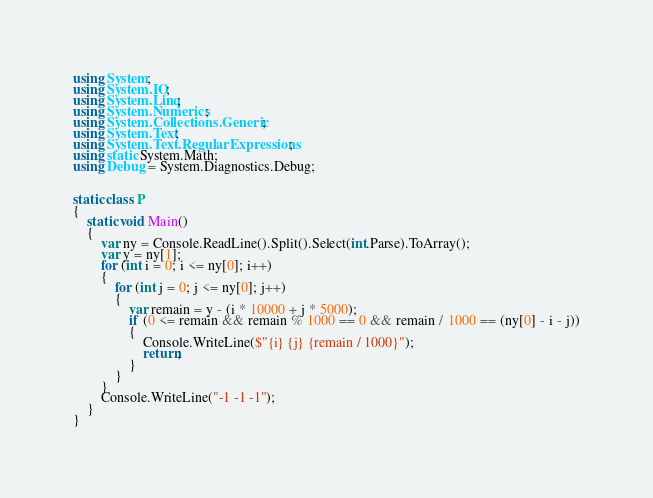<code> <loc_0><loc_0><loc_500><loc_500><_C#_>using System;
using System.IO;
using System.Linq;
using System.Numerics;
using System.Collections.Generic;
using System.Text;
using System.Text.RegularExpressions;
using static System.Math;
using Debug = System.Diagnostics.Debug;


static class P
{
    static void Main()
    {
        var ny = Console.ReadLine().Split().Select(int.Parse).ToArray();
        var y = ny[1];
        for (int i = 0; i <= ny[0]; i++)
        {
            for (int j = 0; j <= ny[0]; j++)
            {
                var remain = y - (i * 10000 + j * 5000);
                if (0 <= remain && remain % 1000 == 0 && remain / 1000 == (ny[0] - i - j))
                {
                    Console.WriteLine($"{i} {j} {remain / 1000}");
                    return;
                }
            }
        }
        Console.WriteLine("-1 -1 -1");
    }
}
</code> 